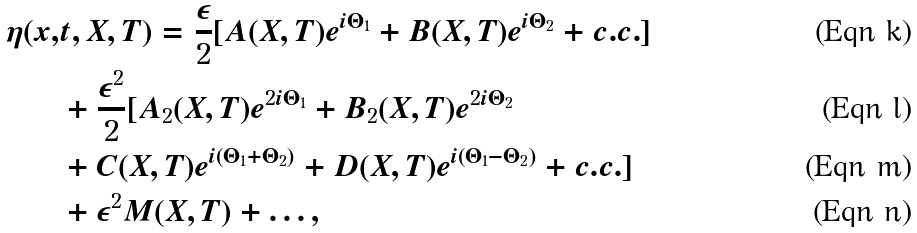<formula> <loc_0><loc_0><loc_500><loc_500>\eta ( x , & t , X , T ) = \frac { \epsilon } { 2 } [ A ( X , T ) e ^ { i \Theta _ { 1 } } + B ( X , T ) e ^ { i \Theta _ { 2 } } + c . c . ] \\ & + \frac { \epsilon ^ { 2 } } { 2 } [ A _ { 2 } ( X , T ) e ^ { 2 i \Theta _ { 1 } } + B _ { 2 } ( X , T ) e ^ { 2 i \Theta _ { 2 } } \\ & + C ( X , T ) e ^ { i ( \Theta _ { 1 } + \Theta _ { 2 } ) } + D ( X , T ) e ^ { i ( \Theta _ { 1 } - \Theta _ { 2 } ) } + c . c . ] \\ & + \epsilon ^ { 2 } M ( X , T ) + \dots ,</formula> 